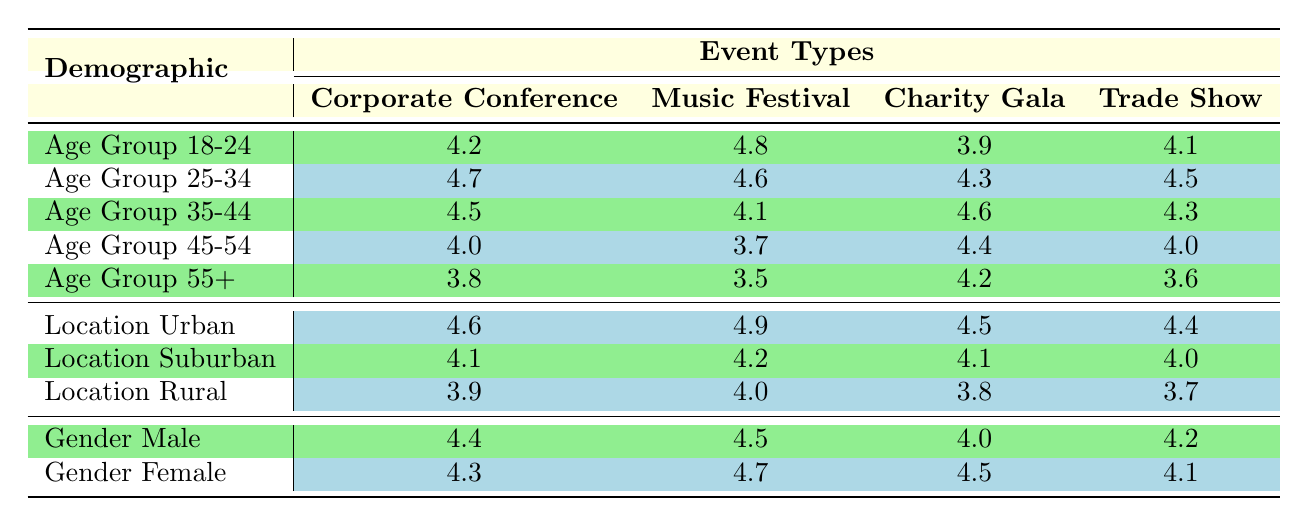What is the feedback score for the Music Festival from the Age Group 25-34? The table shows the feedback score for the Music Festival under the Age Group 25-34, which is listed clearly as 4.6.
Answer: 4.6 Which event type received the highest feedback score from the Location Urban category? The feedback scores for the Location Urban category are: Corporate Conference 4.6, Music Festival 4.9, Charity Gala 4.5, and Trade Show 4.4. The highest value among these is 4.9 for the Music Festival.
Answer: Music Festival Is the feedback score for the Charity Gala higher for Gender Female or Gender Male? The feedback score for Gender Male is 4.0 and for Gender Female is 4.5. Since 4.5 is greater than 4.0, the Charity Gala received a higher score from Gender Female.
Answer: Yes What is the average feedback score for the Age Group 55+ across all event types? The scores for Age Group 55+ are: Corporate Conference 3.8, Music Festival 3.5, Charity Gala 4.2, and Trade Show 3.6. Summing these values gives 3.8 + 3.5 + 4.2 + 3.6 = 15.1. There are 4 event types, so the average is 15.1 / 4 = 3.775.
Answer: 3.775 Did the Age Group 45-54 give a higher feedback score to the Trade Show compared to the Music Festival? The feedback score for the Trade Show from Age Group 45-54 is 4.0, while the Music Festival score is 3.7. Since 4.0 is greater than 3.7, the Age Group 45-54 gave a higher score to the Trade Show.
Answer: Yes Which age group has the highest feedback score for the Corporate Conference? The feedback scores for the Corporate Conference are: 4.2 (18-24), 4.7 (25-34), 4.5 (35-44), 4.0 (45-54), and 3.8 (55+). The highest score is 4.7 from the Age Group 25-34.
Answer: Age Group 25-34 What is the difference between the best feedback score of Gender Male and the lowest of Gender Female across all event types? The highest feedback score for Gender Male is 4.4 (Corporate Conference), and the lowest for Gender Female is 4.1 (Trade Show). The difference is 4.4 - 4.1 = 0.3.
Answer: 0.3 Is the overall feedback from Age Group 18-24 for the Music Festival higher than for the Trade Show? The feedback score for Age Group 18-24 is 4.8 for the Music Festival and 4.1 for the Trade Show. Since 4.8 is greater than 4.1, the feedback from Age Group 18-24 is higher for the Music Festival.
Answer: Yes 